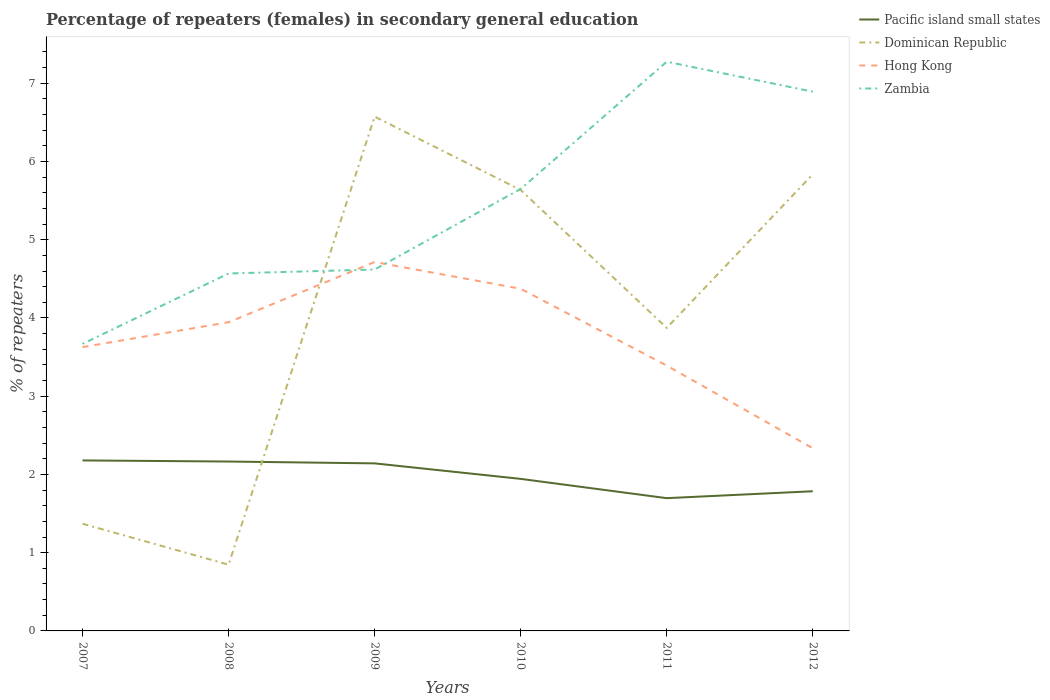How many different coloured lines are there?
Your answer should be very brief. 4. Does the line corresponding to Hong Kong intersect with the line corresponding to Dominican Republic?
Offer a terse response. Yes. Across all years, what is the maximum percentage of female repeaters in Zambia?
Ensure brevity in your answer.  3.67. In which year was the percentage of female repeaters in Pacific island small states maximum?
Provide a succinct answer. 2011. What is the total percentage of female repeaters in Hong Kong in the graph?
Provide a short and direct response. 1.61. What is the difference between the highest and the second highest percentage of female repeaters in Zambia?
Provide a succinct answer. 3.61. How many lines are there?
Offer a very short reply. 4. What is the difference between two consecutive major ticks on the Y-axis?
Provide a short and direct response. 1. Are the values on the major ticks of Y-axis written in scientific E-notation?
Ensure brevity in your answer.  No. What is the title of the graph?
Provide a short and direct response. Percentage of repeaters (females) in secondary general education. What is the label or title of the X-axis?
Ensure brevity in your answer.  Years. What is the label or title of the Y-axis?
Provide a succinct answer. % of repeaters. What is the % of repeaters of Pacific island small states in 2007?
Your answer should be very brief. 2.18. What is the % of repeaters in Dominican Republic in 2007?
Ensure brevity in your answer.  1.37. What is the % of repeaters in Hong Kong in 2007?
Offer a terse response. 3.63. What is the % of repeaters in Zambia in 2007?
Provide a short and direct response. 3.67. What is the % of repeaters of Pacific island small states in 2008?
Your answer should be very brief. 2.16. What is the % of repeaters of Dominican Republic in 2008?
Provide a succinct answer. 0.85. What is the % of repeaters of Hong Kong in 2008?
Keep it short and to the point. 3.95. What is the % of repeaters of Zambia in 2008?
Ensure brevity in your answer.  4.57. What is the % of repeaters in Pacific island small states in 2009?
Keep it short and to the point. 2.14. What is the % of repeaters of Dominican Republic in 2009?
Your response must be concise. 6.57. What is the % of repeaters of Hong Kong in 2009?
Make the answer very short. 4.72. What is the % of repeaters in Zambia in 2009?
Give a very brief answer. 4.62. What is the % of repeaters of Pacific island small states in 2010?
Ensure brevity in your answer.  1.94. What is the % of repeaters of Dominican Republic in 2010?
Ensure brevity in your answer.  5.64. What is the % of repeaters of Hong Kong in 2010?
Your answer should be compact. 4.37. What is the % of repeaters in Zambia in 2010?
Keep it short and to the point. 5.65. What is the % of repeaters of Pacific island small states in 2011?
Keep it short and to the point. 1.7. What is the % of repeaters in Dominican Republic in 2011?
Your answer should be very brief. 3.87. What is the % of repeaters in Hong Kong in 2011?
Offer a terse response. 3.39. What is the % of repeaters of Zambia in 2011?
Keep it short and to the point. 7.27. What is the % of repeaters in Pacific island small states in 2012?
Offer a very short reply. 1.79. What is the % of repeaters in Dominican Republic in 2012?
Your response must be concise. 5.84. What is the % of repeaters of Hong Kong in 2012?
Your response must be concise. 2.33. What is the % of repeaters in Zambia in 2012?
Make the answer very short. 6.89. Across all years, what is the maximum % of repeaters of Pacific island small states?
Your response must be concise. 2.18. Across all years, what is the maximum % of repeaters of Dominican Republic?
Your answer should be compact. 6.57. Across all years, what is the maximum % of repeaters in Hong Kong?
Offer a very short reply. 4.72. Across all years, what is the maximum % of repeaters in Zambia?
Give a very brief answer. 7.27. Across all years, what is the minimum % of repeaters of Pacific island small states?
Ensure brevity in your answer.  1.7. Across all years, what is the minimum % of repeaters of Dominican Republic?
Ensure brevity in your answer.  0.85. Across all years, what is the minimum % of repeaters of Hong Kong?
Make the answer very short. 2.33. Across all years, what is the minimum % of repeaters of Zambia?
Keep it short and to the point. 3.67. What is the total % of repeaters in Pacific island small states in the graph?
Offer a terse response. 11.91. What is the total % of repeaters in Dominican Republic in the graph?
Ensure brevity in your answer.  24.13. What is the total % of repeaters in Hong Kong in the graph?
Make the answer very short. 22.39. What is the total % of repeaters of Zambia in the graph?
Offer a terse response. 32.67. What is the difference between the % of repeaters in Pacific island small states in 2007 and that in 2008?
Provide a succinct answer. 0.01. What is the difference between the % of repeaters in Dominican Republic in 2007 and that in 2008?
Provide a short and direct response. 0.52. What is the difference between the % of repeaters in Hong Kong in 2007 and that in 2008?
Ensure brevity in your answer.  -0.32. What is the difference between the % of repeaters in Zambia in 2007 and that in 2008?
Ensure brevity in your answer.  -0.9. What is the difference between the % of repeaters of Pacific island small states in 2007 and that in 2009?
Your answer should be compact. 0.04. What is the difference between the % of repeaters in Dominican Republic in 2007 and that in 2009?
Make the answer very short. -5.2. What is the difference between the % of repeaters in Hong Kong in 2007 and that in 2009?
Ensure brevity in your answer.  -1.09. What is the difference between the % of repeaters in Zambia in 2007 and that in 2009?
Give a very brief answer. -0.95. What is the difference between the % of repeaters of Pacific island small states in 2007 and that in 2010?
Your response must be concise. 0.24. What is the difference between the % of repeaters in Dominican Republic in 2007 and that in 2010?
Your answer should be compact. -4.27. What is the difference between the % of repeaters in Hong Kong in 2007 and that in 2010?
Ensure brevity in your answer.  -0.75. What is the difference between the % of repeaters in Zambia in 2007 and that in 2010?
Keep it short and to the point. -1.98. What is the difference between the % of repeaters of Pacific island small states in 2007 and that in 2011?
Offer a terse response. 0.48. What is the difference between the % of repeaters in Dominican Republic in 2007 and that in 2011?
Offer a terse response. -2.5. What is the difference between the % of repeaters of Hong Kong in 2007 and that in 2011?
Keep it short and to the point. 0.24. What is the difference between the % of repeaters in Zambia in 2007 and that in 2011?
Offer a terse response. -3.61. What is the difference between the % of repeaters of Pacific island small states in 2007 and that in 2012?
Offer a very short reply. 0.39. What is the difference between the % of repeaters of Dominican Republic in 2007 and that in 2012?
Keep it short and to the point. -4.47. What is the difference between the % of repeaters of Hong Kong in 2007 and that in 2012?
Provide a succinct answer. 1.29. What is the difference between the % of repeaters in Zambia in 2007 and that in 2012?
Provide a succinct answer. -3.22. What is the difference between the % of repeaters in Pacific island small states in 2008 and that in 2009?
Offer a terse response. 0.02. What is the difference between the % of repeaters in Dominican Republic in 2008 and that in 2009?
Offer a very short reply. -5.73. What is the difference between the % of repeaters of Hong Kong in 2008 and that in 2009?
Offer a terse response. -0.77. What is the difference between the % of repeaters in Zambia in 2008 and that in 2009?
Your answer should be very brief. -0.05. What is the difference between the % of repeaters of Pacific island small states in 2008 and that in 2010?
Keep it short and to the point. 0.22. What is the difference between the % of repeaters of Dominican Republic in 2008 and that in 2010?
Offer a very short reply. -4.79. What is the difference between the % of repeaters of Hong Kong in 2008 and that in 2010?
Offer a very short reply. -0.43. What is the difference between the % of repeaters of Zambia in 2008 and that in 2010?
Your response must be concise. -1.08. What is the difference between the % of repeaters of Pacific island small states in 2008 and that in 2011?
Ensure brevity in your answer.  0.47. What is the difference between the % of repeaters of Dominican Republic in 2008 and that in 2011?
Give a very brief answer. -3.03. What is the difference between the % of repeaters of Hong Kong in 2008 and that in 2011?
Keep it short and to the point. 0.55. What is the difference between the % of repeaters in Zambia in 2008 and that in 2011?
Your answer should be very brief. -2.71. What is the difference between the % of repeaters in Pacific island small states in 2008 and that in 2012?
Provide a succinct answer. 0.38. What is the difference between the % of repeaters in Dominican Republic in 2008 and that in 2012?
Provide a succinct answer. -4.99. What is the difference between the % of repeaters in Hong Kong in 2008 and that in 2012?
Your response must be concise. 1.61. What is the difference between the % of repeaters in Zambia in 2008 and that in 2012?
Provide a short and direct response. -2.32. What is the difference between the % of repeaters of Pacific island small states in 2009 and that in 2010?
Offer a terse response. 0.2. What is the difference between the % of repeaters of Dominican Republic in 2009 and that in 2010?
Provide a short and direct response. 0.94. What is the difference between the % of repeaters in Hong Kong in 2009 and that in 2010?
Offer a terse response. 0.34. What is the difference between the % of repeaters in Zambia in 2009 and that in 2010?
Provide a succinct answer. -1.03. What is the difference between the % of repeaters of Pacific island small states in 2009 and that in 2011?
Keep it short and to the point. 0.44. What is the difference between the % of repeaters of Dominican Republic in 2009 and that in 2011?
Give a very brief answer. 2.7. What is the difference between the % of repeaters in Hong Kong in 2009 and that in 2011?
Give a very brief answer. 1.32. What is the difference between the % of repeaters in Zambia in 2009 and that in 2011?
Provide a succinct answer. -2.66. What is the difference between the % of repeaters in Pacific island small states in 2009 and that in 2012?
Offer a very short reply. 0.36. What is the difference between the % of repeaters in Dominican Republic in 2009 and that in 2012?
Your response must be concise. 0.74. What is the difference between the % of repeaters in Hong Kong in 2009 and that in 2012?
Your answer should be very brief. 2.38. What is the difference between the % of repeaters in Zambia in 2009 and that in 2012?
Ensure brevity in your answer.  -2.27. What is the difference between the % of repeaters of Pacific island small states in 2010 and that in 2011?
Give a very brief answer. 0.25. What is the difference between the % of repeaters of Dominican Republic in 2010 and that in 2011?
Your response must be concise. 1.76. What is the difference between the % of repeaters in Hong Kong in 2010 and that in 2011?
Offer a terse response. 0.98. What is the difference between the % of repeaters of Zambia in 2010 and that in 2011?
Your answer should be compact. -1.63. What is the difference between the % of repeaters of Pacific island small states in 2010 and that in 2012?
Provide a short and direct response. 0.16. What is the difference between the % of repeaters of Dominican Republic in 2010 and that in 2012?
Your answer should be very brief. -0.2. What is the difference between the % of repeaters of Hong Kong in 2010 and that in 2012?
Your answer should be very brief. 2.04. What is the difference between the % of repeaters of Zambia in 2010 and that in 2012?
Ensure brevity in your answer.  -1.24. What is the difference between the % of repeaters of Pacific island small states in 2011 and that in 2012?
Provide a succinct answer. -0.09. What is the difference between the % of repeaters of Dominican Republic in 2011 and that in 2012?
Your response must be concise. -1.96. What is the difference between the % of repeaters of Hong Kong in 2011 and that in 2012?
Your response must be concise. 1.06. What is the difference between the % of repeaters of Zambia in 2011 and that in 2012?
Offer a very short reply. 0.38. What is the difference between the % of repeaters of Pacific island small states in 2007 and the % of repeaters of Dominican Republic in 2008?
Provide a short and direct response. 1.33. What is the difference between the % of repeaters of Pacific island small states in 2007 and the % of repeaters of Hong Kong in 2008?
Your answer should be very brief. -1.77. What is the difference between the % of repeaters in Pacific island small states in 2007 and the % of repeaters in Zambia in 2008?
Your answer should be very brief. -2.39. What is the difference between the % of repeaters of Dominican Republic in 2007 and the % of repeaters of Hong Kong in 2008?
Your answer should be compact. -2.58. What is the difference between the % of repeaters in Dominican Republic in 2007 and the % of repeaters in Zambia in 2008?
Your answer should be very brief. -3.2. What is the difference between the % of repeaters of Hong Kong in 2007 and the % of repeaters of Zambia in 2008?
Keep it short and to the point. -0.94. What is the difference between the % of repeaters in Pacific island small states in 2007 and the % of repeaters in Dominican Republic in 2009?
Provide a short and direct response. -4.39. What is the difference between the % of repeaters in Pacific island small states in 2007 and the % of repeaters in Hong Kong in 2009?
Keep it short and to the point. -2.54. What is the difference between the % of repeaters in Pacific island small states in 2007 and the % of repeaters in Zambia in 2009?
Your answer should be compact. -2.44. What is the difference between the % of repeaters of Dominican Republic in 2007 and the % of repeaters of Hong Kong in 2009?
Offer a terse response. -3.35. What is the difference between the % of repeaters of Dominican Republic in 2007 and the % of repeaters of Zambia in 2009?
Make the answer very short. -3.25. What is the difference between the % of repeaters of Hong Kong in 2007 and the % of repeaters of Zambia in 2009?
Your response must be concise. -0.99. What is the difference between the % of repeaters in Pacific island small states in 2007 and the % of repeaters in Dominican Republic in 2010?
Your response must be concise. -3.46. What is the difference between the % of repeaters in Pacific island small states in 2007 and the % of repeaters in Hong Kong in 2010?
Your answer should be very brief. -2.19. What is the difference between the % of repeaters of Pacific island small states in 2007 and the % of repeaters of Zambia in 2010?
Your answer should be very brief. -3.47. What is the difference between the % of repeaters in Dominican Republic in 2007 and the % of repeaters in Hong Kong in 2010?
Your answer should be very brief. -3. What is the difference between the % of repeaters in Dominican Republic in 2007 and the % of repeaters in Zambia in 2010?
Give a very brief answer. -4.28. What is the difference between the % of repeaters in Hong Kong in 2007 and the % of repeaters in Zambia in 2010?
Ensure brevity in your answer.  -2.02. What is the difference between the % of repeaters in Pacific island small states in 2007 and the % of repeaters in Dominican Republic in 2011?
Offer a terse response. -1.69. What is the difference between the % of repeaters of Pacific island small states in 2007 and the % of repeaters of Hong Kong in 2011?
Your response must be concise. -1.21. What is the difference between the % of repeaters of Pacific island small states in 2007 and the % of repeaters of Zambia in 2011?
Make the answer very short. -5.1. What is the difference between the % of repeaters of Dominican Republic in 2007 and the % of repeaters of Hong Kong in 2011?
Offer a very short reply. -2.02. What is the difference between the % of repeaters of Dominican Republic in 2007 and the % of repeaters of Zambia in 2011?
Provide a short and direct response. -5.9. What is the difference between the % of repeaters of Hong Kong in 2007 and the % of repeaters of Zambia in 2011?
Your response must be concise. -3.65. What is the difference between the % of repeaters of Pacific island small states in 2007 and the % of repeaters of Dominican Republic in 2012?
Make the answer very short. -3.66. What is the difference between the % of repeaters in Pacific island small states in 2007 and the % of repeaters in Hong Kong in 2012?
Your answer should be very brief. -0.16. What is the difference between the % of repeaters in Pacific island small states in 2007 and the % of repeaters in Zambia in 2012?
Ensure brevity in your answer.  -4.71. What is the difference between the % of repeaters in Dominican Republic in 2007 and the % of repeaters in Hong Kong in 2012?
Keep it short and to the point. -0.96. What is the difference between the % of repeaters in Dominican Republic in 2007 and the % of repeaters in Zambia in 2012?
Your answer should be compact. -5.52. What is the difference between the % of repeaters in Hong Kong in 2007 and the % of repeaters in Zambia in 2012?
Make the answer very short. -3.26. What is the difference between the % of repeaters in Pacific island small states in 2008 and the % of repeaters in Dominican Republic in 2009?
Ensure brevity in your answer.  -4.41. What is the difference between the % of repeaters of Pacific island small states in 2008 and the % of repeaters of Hong Kong in 2009?
Provide a short and direct response. -2.55. What is the difference between the % of repeaters of Pacific island small states in 2008 and the % of repeaters of Zambia in 2009?
Provide a short and direct response. -2.45. What is the difference between the % of repeaters in Dominican Republic in 2008 and the % of repeaters in Hong Kong in 2009?
Your response must be concise. -3.87. What is the difference between the % of repeaters in Dominican Republic in 2008 and the % of repeaters in Zambia in 2009?
Your answer should be very brief. -3.77. What is the difference between the % of repeaters of Hong Kong in 2008 and the % of repeaters of Zambia in 2009?
Provide a short and direct response. -0.67. What is the difference between the % of repeaters in Pacific island small states in 2008 and the % of repeaters in Dominican Republic in 2010?
Offer a very short reply. -3.47. What is the difference between the % of repeaters of Pacific island small states in 2008 and the % of repeaters of Hong Kong in 2010?
Your answer should be very brief. -2.21. What is the difference between the % of repeaters of Pacific island small states in 2008 and the % of repeaters of Zambia in 2010?
Your answer should be very brief. -3.48. What is the difference between the % of repeaters of Dominican Republic in 2008 and the % of repeaters of Hong Kong in 2010?
Your answer should be compact. -3.53. What is the difference between the % of repeaters of Dominican Republic in 2008 and the % of repeaters of Zambia in 2010?
Offer a very short reply. -4.8. What is the difference between the % of repeaters of Hong Kong in 2008 and the % of repeaters of Zambia in 2010?
Your response must be concise. -1.7. What is the difference between the % of repeaters in Pacific island small states in 2008 and the % of repeaters in Dominican Republic in 2011?
Offer a terse response. -1.71. What is the difference between the % of repeaters of Pacific island small states in 2008 and the % of repeaters of Hong Kong in 2011?
Provide a succinct answer. -1.23. What is the difference between the % of repeaters in Pacific island small states in 2008 and the % of repeaters in Zambia in 2011?
Offer a very short reply. -5.11. What is the difference between the % of repeaters in Dominican Republic in 2008 and the % of repeaters in Hong Kong in 2011?
Your response must be concise. -2.54. What is the difference between the % of repeaters of Dominican Republic in 2008 and the % of repeaters of Zambia in 2011?
Make the answer very short. -6.43. What is the difference between the % of repeaters in Hong Kong in 2008 and the % of repeaters in Zambia in 2011?
Your answer should be very brief. -3.33. What is the difference between the % of repeaters of Pacific island small states in 2008 and the % of repeaters of Dominican Republic in 2012?
Keep it short and to the point. -3.67. What is the difference between the % of repeaters of Pacific island small states in 2008 and the % of repeaters of Hong Kong in 2012?
Offer a terse response. -0.17. What is the difference between the % of repeaters in Pacific island small states in 2008 and the % of repeaters in Zambia in 2012?
Give a very brief answer. -4.73. What is the difference between the % of repeaters in Dominican Republic in 2008 and the % of repeaters in Hong Kong in 2012?
Provide a short and direct response. -1.49. What is the difference between the % of repeaters of Dominican Republic in 2008 and the % of repeaters of Zambia in 2012?
Your answer should be very brief. -6.05. What is the difference between the % of repeaters in Hong Kong in 2008 and the % of repeaters in Zambia in 2012?
Give a very brief answer. -2.95. What is the difference between the % of repeaters of Pacific island small states in 2009 and the % of repeaters of Dominican Republic in 2010?
Keep it short and to the point. -3.49. What is the difference between the % of repeaters of Pacific island small states in 2009 and the % of repeaters of Hong Kong in 2010?
Offer a terse response. -2.23. What is the difference between the % of repeaters of Pacific island small states in 2009 and the % of repeaters of Zambia in 2010?
Make the answer very short. -3.51. What is the difference between the % of repeaters of Dominican Republic in 2009 and the % of repeaters of Hong Kong in 2010?
Give a very brief answer. 2.2. What is the difference between the % of repeaters of Dominican Republic in 2009 and the % of repeaters of Zambia in 2010?
Make the answer very short. 0.92. What is the difference between the % of repeaters in Hong Kong in 2009 and the % of repeaters in Zambia in 2010?
Your response must be concise. -0.93. What is the difference between the % of repeaters of Pacific island small states in 2009 and the % of repeaters of Dominican Republic in 2011?
Your answer should be very brief. -1.73. What is the difference between the % of repeaters in Pacific island small states in 2009 and the % of repeaters in Hong Kong in 2011?
Give a very brief answer. -1.25. What is the difference between the % of repeaters in Pacific island small states in 2009 and the % of repeaters in Zambia in 2011?
Offer a very short reply. -5.13. What is the difference between the % of repeaters in Dominican Republic in 2009 and the % of repeaters in Hong Kong in 2011?
Keep it short and to the point. 3.18. What is the difference between the % of repeaters in Dominican Republic in 2009 and the % of repeaters in Zambia in 2011?
Your answer should be very brief. -0.7. What is the difference between the % of repeaters of Hong Kong in 2009 and the % of repeaters of Zambia in 2011?
Keep it short and to the point. -2.56. What is the difference between the % of repeaters of Pacific island small states in 2009 and the % of repeaters of Dominican Republic in 2012?
Your answer should be very brief. -3.69. What is the difference between the % of repeaters in Pacific island small states in 2009 and the % of repeaters in Hong Kong in 2012?
Your response must be concise. -0.19. What is the difference between the % of repeaters of Pacific island small states in 2009 and the % of repeaters of Zambia in 2012?
Provide a succinct answer. -4.75. What is the difference between the % of repeaters of Dominican Republic in 2009 and the % of repeaters of Hong Kong in 2012?
Provide a short and direct response. 4.24. What is the difference between the % of repeaters of Dominican Republic in 2009 and the % of repeaters of Zambia in 2012?
Your response must be concise. -0.32. What is the difference between the % of repeaters in Hong Kong in 2009 and the % of repeaters in Zambia in 2012?
Offer a very short reply. -2.18. What is the difference between the % of repeaters of Pacific island small states in 2010 and the % of repeaters of Dominican Republic in 2011?
Provide a succinct answer. -1.93. What is the difference between the % of repeaters in Pacific island small states in 2010 and the % of repeaters in Hong Kong in 2011?
Your answer should be compact. -1.45. What is the difference between the % of repeaters of Pacific island small states in 2010 and the % of repeaters of Zambia in 2011?
Offer a terse response. -5.33. What is the difference between the % of repeaters in Dominican Republic in 2010 and the % of repeaters in Hong Kong in 2011?
Your response must be concise. 2.24. What is the difference between the % of repeaters in Dominican Republic in 2010 and the % of repeaters in Zambia in 2011?
Provide a short and direct response. -1.64. What is the difference between the % of repeaters of Hong Kong in 2010 and the % of repeaters of Zambia in 2011?
Keep it short and to the point. -2.9. What is the difference between the % of repeaters of Pacific island small states in 2010 and the % of repeaters of Dominican Republic in 2012?
Offer a terse response. -3.89. What is the difference between the % of repeaters in Pacific island small states in 2010 and the % of repeaters in Hong Kong in 2012?
Provide a short and direct response. -0.39. What is the difference between the % of repeaters in Pacific island small states in 2010 and the % of repeaters in Zambia in 2012?
Your response must be concise. -4.95. What is the difference between the % of repeaters of Dominican Republic in 2010 and the % of repeaters of Hong Kong in 2012?
Your answer should be very brief. 3.3. What is the difference between the % of repeaters of Dominican Republic in 2010 and the % of repeaters of Zambia in 2012?
Keep it short and to the point. -1.26. What is the difference between the % of repeaters in Hong Kong in 2010 and the % of repeaters in Zambia in 2012?
Make the answer very short. -2.52. What is the difference between the % of repeaters in Pacific island small states in 2011 and the % of repeaters in Dominican Republic in 2012?
Offer a terse response. -4.14. What is the difference between the % of repeaters in Pacific island small states in 2011 and the % of repeaters in Hong Kong in 2012?
Provide a succinct answer. -0.64. What is the difference between the % of repeaters in Pacific island small states in 2011 and the % of repeaters in Zambia in 2012?
Ensure brevity in your answer.  -5.2. What is the difference between the % of repeaters of Dominican Republic in 2011 and the % of repeaters of Hong Kong in 2012?
Keep it short and to the point. 1.54. What is the difference between the % of repeaters of Dominican Republic in 2011 and the % of repeaters of Zambia in 2012?
Ensure brevity in your answer.  -3.02. What is the difference between the % of repeaters of Hong Kong in 2011 and the % of repeaters of Zambia in 2012?
Make the answer very short. -3.5. What is the average % of repeaters of Pacific island small states per year?
Your answer should be compact. 1.99. What is the average % of repeaters of Dominican Republic per year?
Keep it short and to the point. 4.02. What is the average % of repeaters in Hong Kong per year?
Ensure brevity in your answer.  3.73. What is the average % of repeaters of Zambia per year?
Your answer should be compact. 5.45. In the year 2007, what is the difference between the % of repeaters in Pacific island small states and % of repeaters in Dominican Republic?
Provide a succinct answer. 0.81. In the year 2007, what is the difference between the % of repeaters of Pacific island small states and % of repeaters of Hong Kong?
Your response must be concise. -1.45. In the year 2007, what is the difference between the % of repeaters in Pacific island small states and % of repeaters in Zambia?
Give a very brief answer. -1.49. In the year 2007, what is the difference between the % of repeaters of Dominican Republic and % of repeaters of Hong Kong?
Make the answer very short. -2.26. In the year 2007, what is the difference between the % of repeaters of Dominican Republic and % of repeaters of Zambia?
Provide a short and direct response. -2.3. In the year 2007, what is the difference between the % of repeaters in Hong Kong and % of repeaters in Zambia?
Give a very brief answer. -0.04. In the year 2008, what is the difference between the % of repeaters of Pacific island small states and % of repeaters of Dominican Republic?
Your answer should be very brief. 1.32. In the year 2008, what is the difference between the % of repeaters in Pacific island small states and % of repeaters in Hong Kong?
Make the answer very short. -1.78. In the year 2008, what is the difference between the % of repeaters of Pacific island small states and % of repeaters of Zambia?
Your answer should be compact. -2.4. In the year 2008, what is the difference between the % of repeaters in Dominican Republic and % of repeaters in Hong Kong?
Your answer should be very brief. -3.1. In the year 2008, what is the difference between the % of repeaters in Dominican Republic and % of repeaters in Zambia?
Your response must be concise. -3.72. In the year 2008, what is the difference between the % of repeaters of Hong Kong and % of repeaters of Zambia?
Your answer should be compact. -0.62. In the year 2009, what is the difference between the % of repeaters in Pacific island small states and % of repeaters in Dominican Republic?
Provide a short and direct response. -4.43. In the year 2009, what is the difference between the % of repeaters in Pacific island small states and % of repeaters in Hong Kong?
Offer a terse response. -2.57. In the year 2009, what is the difference between the % of repeaters in Pacific island small states and % of repeaters in Zambia?
Offer a very short reply. -2.48. In the year 2009, what is the difference between the % of repeaters of Dominican Republic and % of repeaters of Hong Kong?
Provide a short and direct response. 1.86. In the year 2009, what is the difference between the % of repeaters of Dominican Republic and % of repeaters of Zambia?
Your answer should be compact. 1.95. In the year 2009, what is the difference between the % of repeaters of Hong Kong and % of repeaters of Zambia?
Offer a very short reply. 0.1. In the year 2010, what is the difference between the % of repeaters of Pacific island small states and % of repeaters of Dominican Republic?
Ensure brevity in your answer.  -3.69. In the year 2010, what is the difference between the % of repeaters of Pacific island small states and % of repeaters of Hong Kong?
Provide a succinct answer. -2.43. In the year 2010, what is the difference between the % of repeaters of Pacific island small states and % of repeaters of Zambia?
Your response must be concise. -3.71. In the year 2010, what is the difference between the % of repeaters in Dominican Republic and % of repeaters in Hong Kong?
Give a very brief answer. 1.26. In the year 2010, what is the difference between the % of repeaters of Dominican Republic and % of repeaters of Zambia?
Provide a succinct answer. -0.01. In the year 2010, what is the difference between the % of repeaters of Hong Kong and % of repeaters of Zambia?
Your answer should be compact. -1.28. In the year 2011, what is the difference between the % of repeaters in Pacific island small states and % of repeaters in Dominican Republic?
Make the answer very short. -2.18. In the year 2011, what is the difference between the % of repeaters of Pacific island small states and % of repeaters of Hong Kong?
Make the answer very short. -1.69. In the year 2011, what is the difference between the % of repeaters of Pacific island small states and % of repeaters of Zambia?
Offer a very short reply. -5.58. In the year 2011, what is the difference between the % of repeaters of Dominican Republic and % of repeaters of Hong Kong?
Make the answer very short. 0.48. In the year 2011, what is the difference between the % of repeaters of Dominican Republic and % of repeaters of Zambia?
Provide a short and direct response. -3.4. In the year 2011, what is the difference between the % of repeaters in Hong Kong and % of repeaters in Zambia?
Ensure brevity in your answer.  -3.88. In the year 2012, what is the difference between the % of repeaters in Pacific island small states and % of repeaters in Dominican Republic?
Keep it short and to the point. -4.05. In the year 2012, what is the difference between the % of repeaters of Pacific island small states and % of repeaters of Hong Kong?
Provide a succinct answer. -0.55. In the year 2012, what is the difference between the % of repeaters in Pacific island small states and % of repeaters in Zambia?
Offer a very short reply. -5.11. In the year 2012, what is the difference between the % of repeaters in Dominican Republic and % of repeaters in Hong Kong?
Your answer should be compact. 3.5. In the year 2012, what is the difference between the % of repeaters of Dominican Republic and % of repeaters of Zambia?
Provide a short and direct response. -1.06. In the year 2012, what is the difference between the % of repeaters of Hong Kong and % of repeaters of Zambia?
Keep it short and to the point. -4.56. What is the ratio of the % of repeaters of Pacific island small states in 2007 to that in 2008?
Provide a succinct answer. 1.01. What is the ratio of the % of repeaters in Dominican Republic in 2007 to that in 2008?
Offer a terse response. 1.62. What is the ratio of the % of repeaters of Hong Kong in 2007 to that in 2008?
Your response must be concise. 0.92. What is the ratio of the % of repeaters of Zambia in 2007 to that in 2008?
Provide a succinct answer. 0.8. What is the ratio of the % of repeaters of Pacific island small states in 2007 to that in 2009?
Your response must be concise. 1.02. What is the ratio of the % of repeaters in Dominican Republic in 2007 to that in 2009?
Offer a very short reply. 0.21. What is the ratio of the % of repeaters of Hong Kong in 2007 to that in 2009?
Your answer should be very brief. 0.77. What is the ratio of the % of repeaters in Zambia in 2007 to that in 2009?
Make the answer very short. 0.79. What is the ratio of the % of repeaters in Pacific island small states in 2007 to that in 2010?
Your answer should be very brief. 1.12. What is the ratio of the % of repeaters of Dominican Republic in 2007 to that in 2010?
Keep it short and to the point. 0.24. What is the ratio of the % of repeaters of Hong Kong in 2007 to that in 2010?
Make the answer very short. 0.83. What is the ratio of the % of repeaters of Zambia in 2007 to that in 2010?
Ensure brevity in your answer.  0.65. What is the ratio of the % of repeaters in Pacific island small states in 2007 to that in 2011?
Provide a succinct answer. 1.28. What is the ratio of the % of repeaters of Dominican Republic in 2007 to that in 2011?
Your answer should be compact. 0.35. What is the ratio of the % of repeaters of Hong Kong in 2007 to that in 2011?
Ensure brevity in your answer.  1.07. What is the ratio of the % of repeaters of Zambia in 2007 to that in 2011?
Offer a terse response. 0.5. What is the ratio of the % of repeaters in Pacific island small states in 2007 to that in 2012?
Give a very brief answer. 1.22. What is the ratio of the % of repeaters of Dominican Republic in 2007 to that in 2012?
Your answer should be compact. 0.23. What is the ratio of the % of repeaters in Hong Kong in 2007 to that in 2012?
Make the answer very short. 1.55. What is the ratio of the % of repeaters in Zambia in 2007 to that in 2012?
Your answer should be compact. 0.53. What is the ratio of the % of repeaters in Dominican Republic in 2008 to that in 2009?
Provide a short and direct response. 0.13. What is the ratio of the % of repeaters in Hong Kong in 2008 to that in 2009?
Your answer should be compact. 0.84. What is the ratio of the % of repeaters of Pacific island small states in 2008 to that in 2010?
Provide a succinct answer. 1.11. What is the ratio of the % of repeaters in Dominican Republic in 2008 to that in 2010?
Offer a terse response. 0.15. What is the ratio of the % of repeaters in Hong Kong in 2008 to that in 2010?
Your response must be concise. 0.9. What is the ratio of the % of repeaters in Zambia in 2008 to that in 2010?
Provide a succinct answer. 0.81. What is the ratio of the % of repeaters of Pacific island small states in 2008 to that in 2011?
Keep it short and to the point. 1.28. What is the ratio of the % of repeaters in Dominican Republic in 2008 to that in 2011?
Your answer should be compact. 0.22. What is the ratio of the % of repeaters in Hong Kong in 2008 to that in 2011?
Make the answer very short. 1.16. What is the ratio of the % of repeaters of Zambia in 2008 to that in 2011?
Give a very brief answer. 0.63. What is the ratio of the % of repeaters of Pacific island small states in 2008 to that in 2012?
Your answer should be very brief. 1.21. What is the ratio of the % of repeaters in Dominican Republic in 2008 to that in 2012?
Offer a terse response. 0.15. What is the ratio of the % of repeaters of Hong Kong in 2008 to that in 2012?
Make the answer very short. 1.69. What is the ratio of the % of repeaters of Zambia in 2008 to that in 2012?
Your response must be concise. 0.66. What is the ratio of the % of repeaters in Pacific island small states in 2009 to that in 2010?
Your response must be concise. 1.1. What is the ratio of the % of repeaters in Dominican Republic in 2009 to that in 2010?
Your response must be concise. 1.17. What is the ratio of the % of repeaters of Hong Kong in 2009 to that in 2010?
Offer a terse response. 1.08. What is the ratio of the % of repeaters in Zambia in 2009 to that in 2010?
Offer a very short reply. 0.82. What is the ratio of the % of repeaters of Pacific island small states in 2009 to that in 2011?
Offer a very short reply. 1.26. What is the ratio of the % of repeaters in Dominican Republic in 2009 to that in 2011?
Provide a succinct answer. 1.7. What is the ratio of the % of repeaters in Hong Kong in 2009 to that in 2011?
Keep it short and to the point. 1.39. What is the ratio of the % of repeaters of Zambia in 2009 to that in 2011?
Your answer should be compact. 0.63. What is the ratio of the % of repeaters in Pacific island small states in 2009 to that in 2012?
Give a very brief answer. 1.2. What is the ratio of the % of repeaters of Dominican Republic in 2009 to that in 2012?
Your response must be concise. 1.13. What is the ratio of the % of repeaters in Hong Kong in 2009 to that in 2012?
Offer a very short reply. 2.02. What is the ratio of the % of repeaters of Zambia in 2009 to that in 2012?
Your response must be concise. 0.67. What is the ratio of the % of repeaters in Pacific island small states in 2010 to that in 2011?
Make the answer very short. 1.15. What is the ratio of the % of repeaters of Dominican Republic in 2010 to that in 2011?
Provide a short and direct response. 1.46. What is the ratio of the % of repeaters in Hong Kong in 2010 to that in 2011?
Ensure brevity in your answer.  1.29. What is the ratio of the % of repeaters in Zambia in 2010 to that in 2011?
Your answer should be compact. 0.78. What is the ratio of the % of repeaters in Pacific island small states in 2010 to that in 2012?
Provide a short and direct response. 1.09. What is the ratio of the % of repeaters in Dominican Republic in 2010 to that in 2012?
Offer a very short reply. 0.97. What is the ratio of the % of repeaters of Hong Kong in 2010 to that in 2012?
Provide a short and direct response. 1.87. What is the ratio of the % of repeaters of Zambia in 2010 to that in 2012?
Provide a succinct answer. 0.82. What is the ratio of the % of repeaters of Pacific island small states in 2011 to that in 2012?
Make the answer very short. 0.95. What is the ratio of the % of repeaters in Dominican Republic in 2011 to that in 2012?
Make the answer very short. 0.66. What is the ratio of the % of repeaters in Hong Kong in 2011 to that in 2012?
Keep it short and to the point. 1.45. What is the ratio of the % of repeaters of Zambia in 2011 to that in 2012?
Make the answer very short. 1.06. What is the difference between the highest and the second highest % of repeaters in Pacific island small states?
Offer a very short reply. 0.01. What is the difference between the highest and the second highest % of repeaters in Dominican Republic?
Make the answer very short. 0.74. What is the difference between the highest and the second highest % of repeaters in Hong Kong?
Offer a very short reply. 0.34. What is the difference between the highest and the second highest % of repeaters in Zambia?
Give a very brief answer. 0.38. What is the difference between the highest and the lowest % of repeaters of Pacific island small states?
Your answer should be very brief. 0.48. What is the difference between the highest and the lowest % of repeaters of Dominican Republic?
Your response must be concise. 5.73. What is the difference between the highest and the lowest % of repeaters of Hong Kong?
Give a very brief answer. 2.38. What is the difference between the highest and the lowest % of repeaters in Zambia?
Make the answer very short. 3.61. 